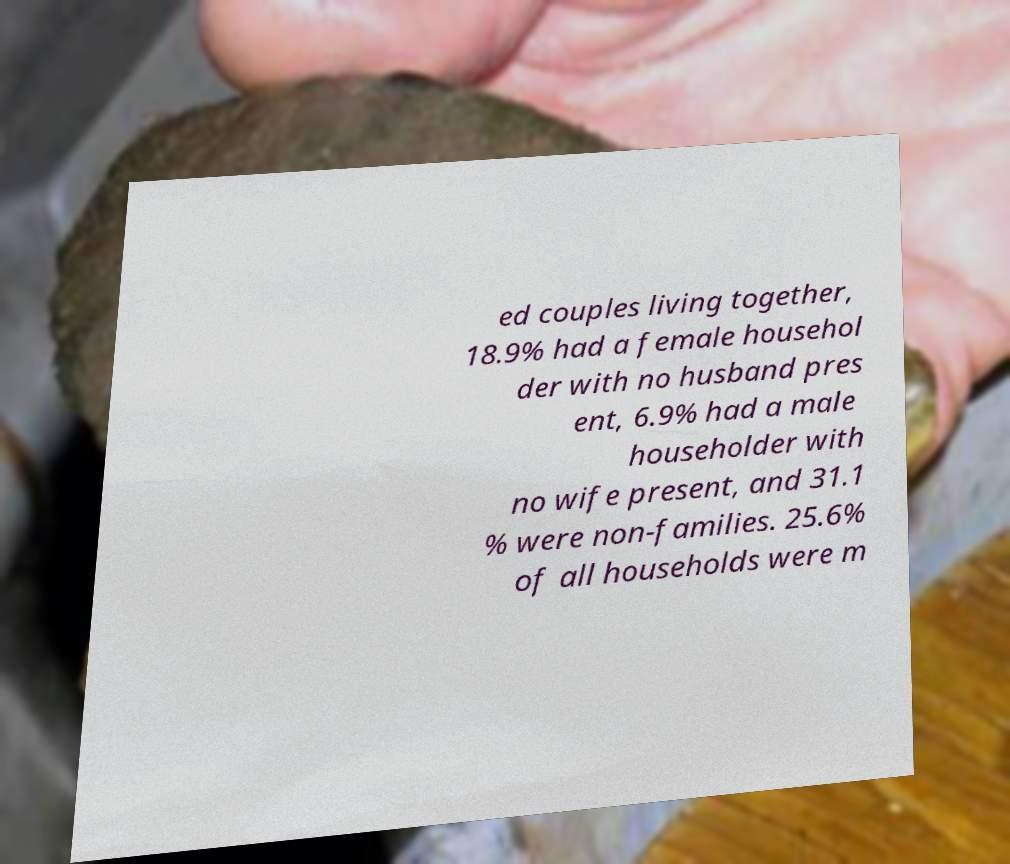For documentation purposes, I need the text within this image transcribed. Could you provide that? ed couples living together, 18.9% had a female househol der with no husband pres ent, 6.9% had a male householder with no wife present, and 31.1 % were non-families. 25.6% of all households were m 